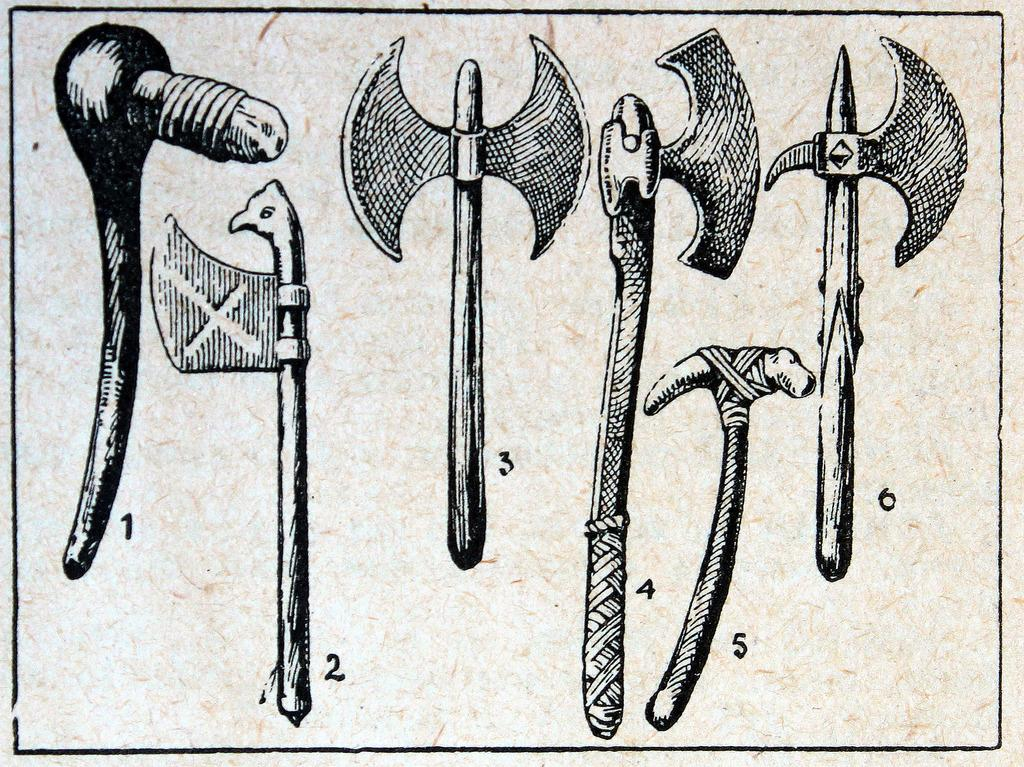What type of objects can be seen in the image? There are tools depicted in the image. Are there any written elements in the image? Yes, there are numbers written in the image. What is the color scheme of the image? The image is black and white in color. How many snails can be seen in the image? There are no snails present in the image; it features tools and numbers. 